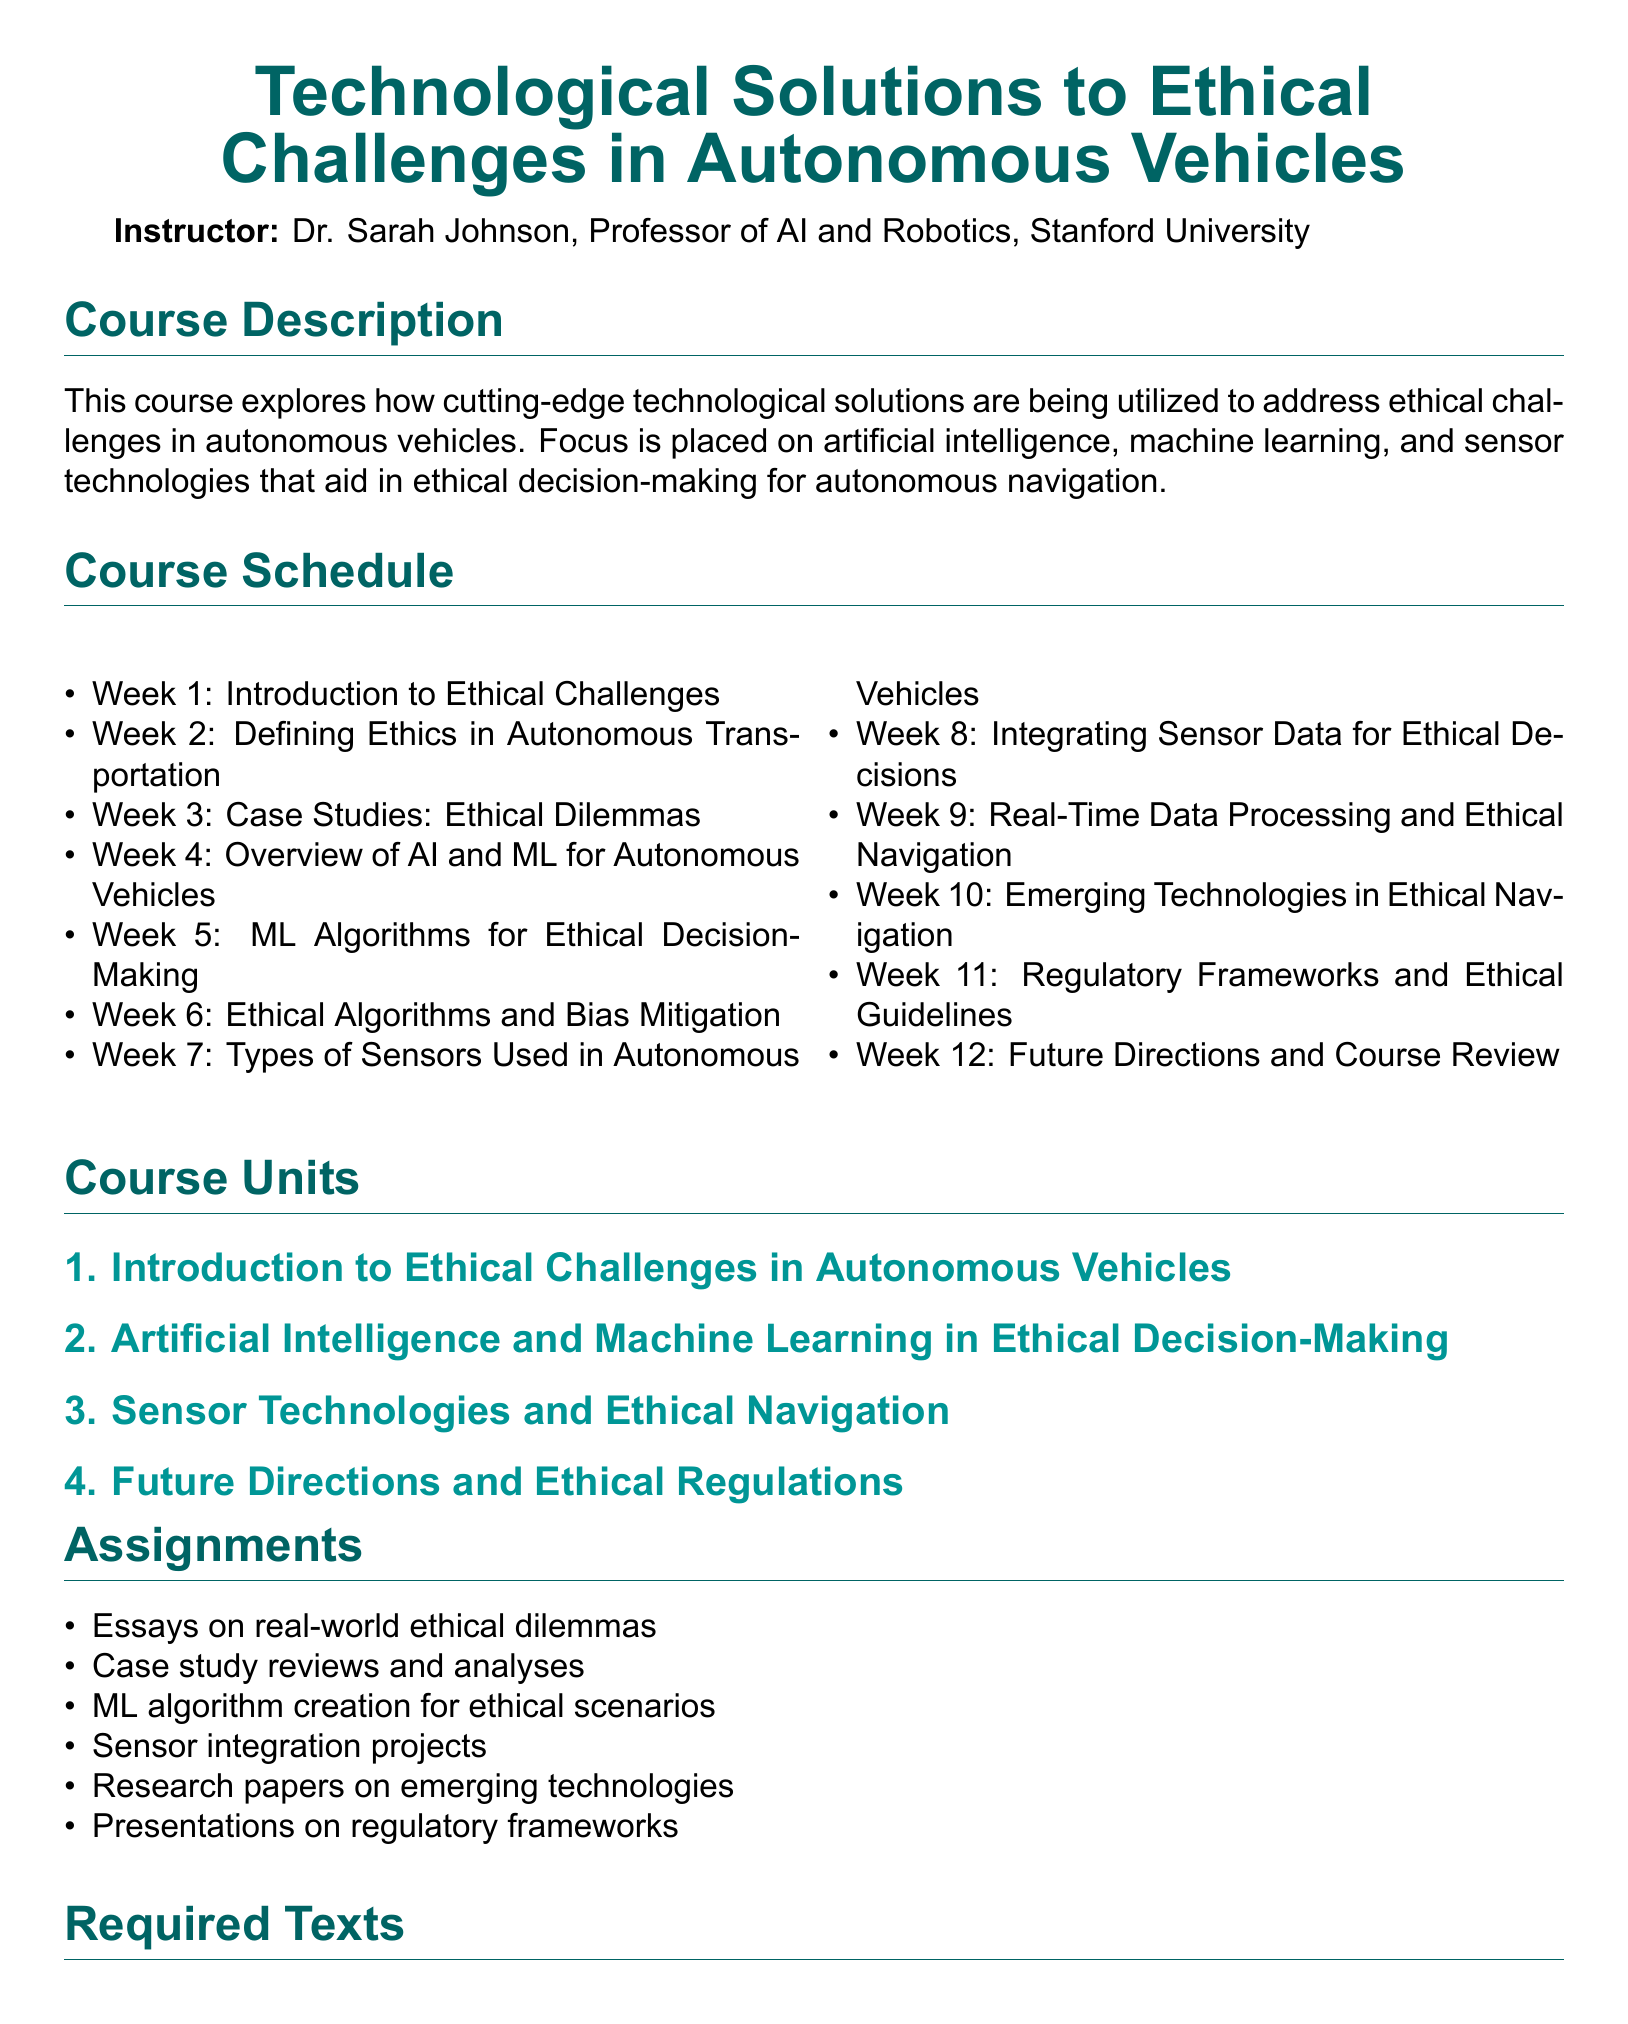What is the name of the instructor? The instructor's name is listed at the beginning of the document as Dr. Sarah Johnson.
Answer: Dr. Sarah Johnson What is the focus of the course? The course description specifically mentions the focus is on artificial intelligence, machine learning, and sensor technologies for ethical decision-making.
Answer: Ethical decision-making How many weeks is the course scheduled for? The course schedule indicates there are 12 weeks outlined in the course.
Answer: 12 Which week covers case studies of ethical dilemmas? The course schedule lists Week 3 for case studies focusing on ethical dilemmas.
Answer: Week 3 What is one of the required texts for the course? The required texts section includes several titles, and one is 'Ethics of AI' by Nick Bostrom.
Answer: 'Ethics of AI' What is the first unit of the course? The course units section lists "Introduction to Ethical Challenges in Autonomous Vehicles" as the first unit.
Answer: Introduction to Ethical Challenges in Autonomous Vehicles What type of assignment involves real-world ethical dilemmas? The assignments section indicates that essays on real-world ethical dilemmas are required.
Answer: Essays Which week discusses regulatory frameworks? According to the course schedule, Week 11 is dedicated to regulatory frameworks and ethical guidelines.
Answer: Week 11 What technology is integrated for ethical decisions according to the syllabus? The syllabus explains that sensor data is integrated for ethical decision-making in vehicles.
Answer: Sensor data 